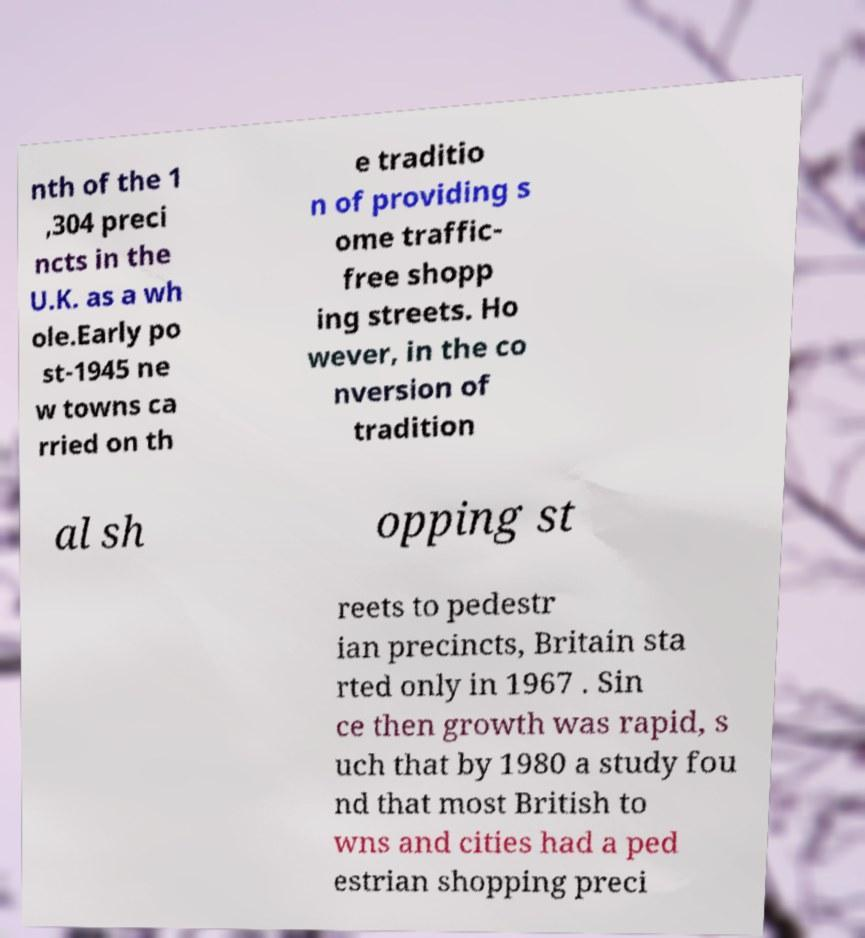Can you accurately transcribe the text from the provided image for me? nth of the 1 ,304 preci ncts in the U.K. as a wh ole.Early po st-1945 ne w towns ca rried on th e traditio n of providing s ome traffic- free shopp ing streets. Ho wever, in the co nversion of tradition al sh opping st reets to pedestr ian precincts, Britain sta rted only in 1967 . Sin ce then growth was rapid, s uch that by 1980 a study fou nd that most British to wns and cities had a ped estrian shopping preci 